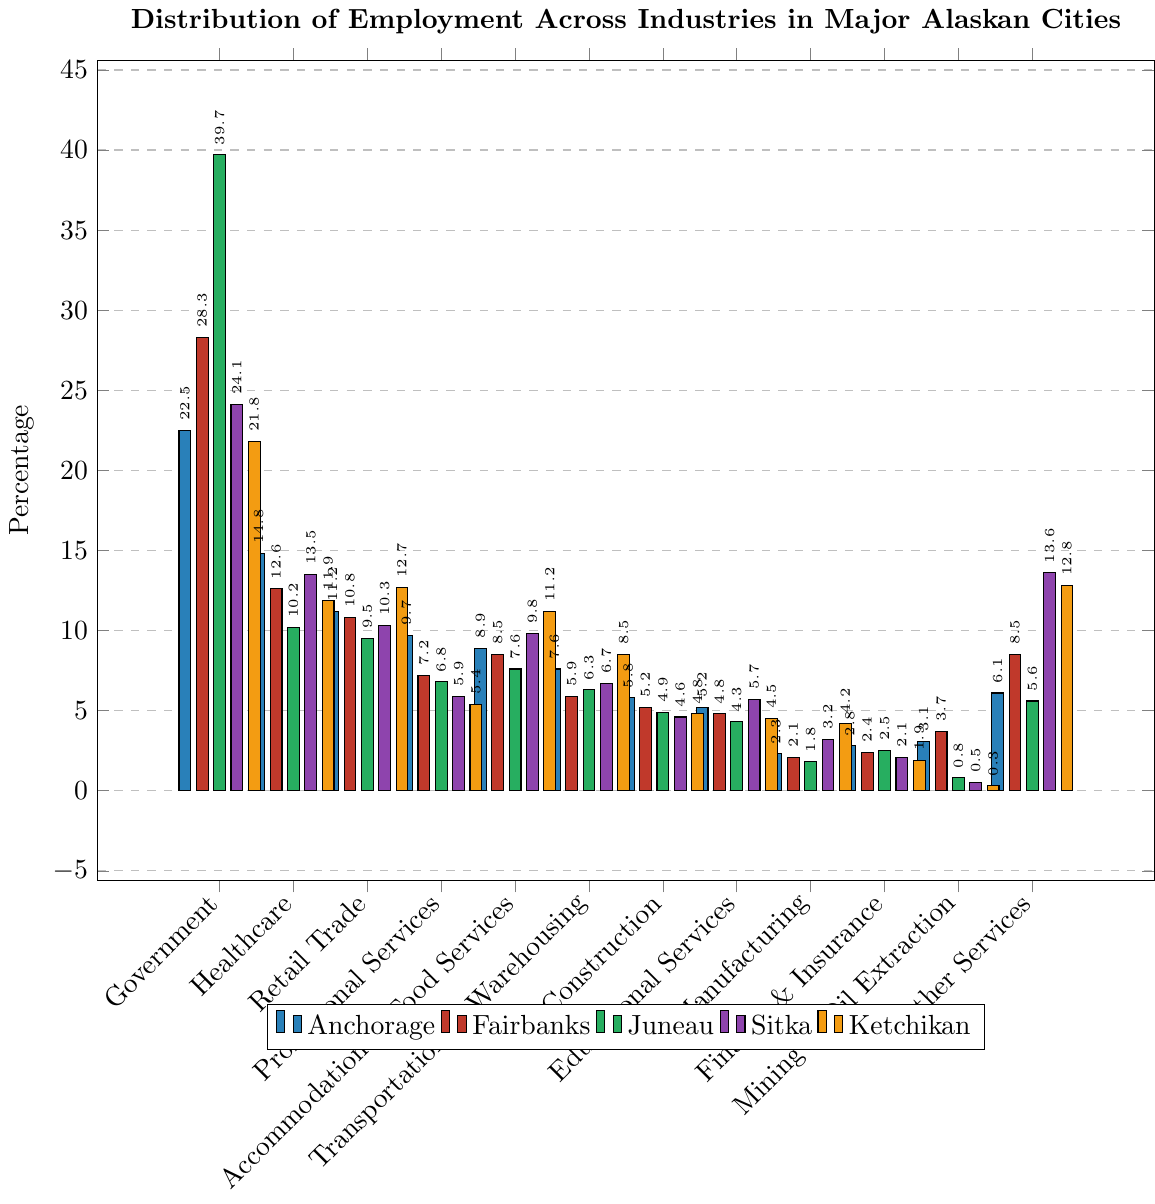What industry has the highest employment for Anchorage? By examining the bar heights for Anchorage, it is clear that the bar for Government employment in Anchorage is the tallest. Therefore, Government has the highest employment percentage in Anchorage.
Answer: Government Which city has the lowest percentage of employment in Mining & Oil Extraction? Comparing the bar heights for Mining & Oil Extraction across all cities, Ketchikan has the shortest bar, indicating the lowest percentage.
Answer: Ketchikan How does the employment percentage of Retail Trade in Anchorage compare to Ketchikan? The bar for Retail Trade in Anchorage is lower than the bar for Retail Trade in Ketchikan, indicating a lower employment percentage. Anchorage is at 11.2%, and Ketchikan is at 12.7%.
Answer: Anchorage's percentage is lower What is the difference in employment percentage in Professional Services between Anchorage and Fairbanks? The bar for Professional Services in Anchorage is at 9.7%, while Fairbanks is at 7.2%. Subtracting these percentages gives 9.7% - 7.2% = 2.5%.
Answer: 2.5% Which city has the highest employment percentage in Other Services, and what is that percentage? Examining the bar heights for Other Services, Sitka has the highest, with the bar reaching 13.6%.
Answer: Sitka, 13.6% What is the average employment percentage for Healthcare across all five cities? Adding the Healthcare percentages for all cities: 14.8% (Anchorage) + 12.6% (Fairbanks) + 10.2% (Juneau) + 13.5% (Sitka) + 11.9% (Ketchikan) = 63.0%. Dividing by 5 gives the average: 63.0 / 5 = 12.6%.
Answer: 12.6% If you sum the employment percentages for Manufacturing and Finance & Insurance in Anchorage, what do you get? For Anchorage, Manufacturing is at 2.3% and Finance & Insurance is at 2.8%. Summing these gives 2.3% + 2.8% = 5.1%.
Answer: 5.1% Which has a lower employment percentage in Juneau: Government or Healthcare? The bar for Government in Juneau is higher than the one for Healthcare. Government is at 39.7%, whereas Healthcare is at 10.2%.
Answer: Healthcare In which city is the employment percentage in Education Services the same as the one in Manufacturing the highest? Examine the Education Services and Manufacturing bars for all cities. The shortest bars for Education Services is in Juneau (4.3%), which is close to the bar for Manufacturing in Ketchikan (4.2%). The exact values are highest for Juneau in Education, highest for Ketchikan in Manufacturing.
Answer: Juneau or Ketchikan What is the sum of the employment percentages for Accommodation & Food Services and Transportation & Warehousing in Ketchikan? Accommodation & Food Services is at 11.2% and Transportation & Warehousing is at 8.5% in Ketchikan. Summing these percentages gives 11.2% + 8.5% = 19.7%.
Answer: 19.7% 